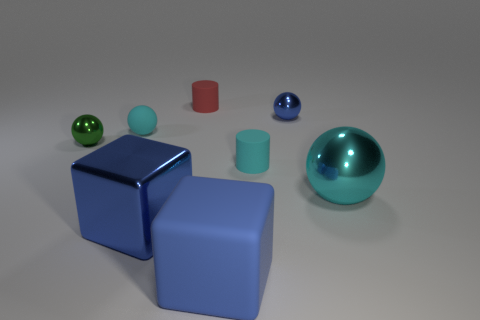How many cylinders are behind the small cyan matte object that is behind the rubber object that is on the right side of the large blue rubber cube?
Your answer should be compact. 1. What is the color of the tiny matte object in front of the tiny green sphere?
Provide a short and direct response. Cyan. What is the ball that is both left of the large matte cube and behind the tiny green shiny object made of?
Offer a terse response. Rubber. How many green balls are left of the shiny thing that is in front of the large cyan sphere?
Make the answer very short. 1. What is the shape of the blue matte thing?
Keep it short and to the point. Cube. There is a big blue object that is made of the same material as the small red cylinder; what shape is it?
Your response must be concise. Cube. There is a blue metal thing that is behind the green shiny thing; does it have the same shape as the green thing?
Your answer should be very brief. Yes. The cyan object to the right of the small blue shiny thing has what shape?
Offer a terse response. Sphere. There is a big thing that is the same color as the rubber ball; what shape is it?
Your answer should be compact. Sphere. How many red matte spheres are the same size as the cyan matte cylinder?
Provide a short and direct response. 0. 